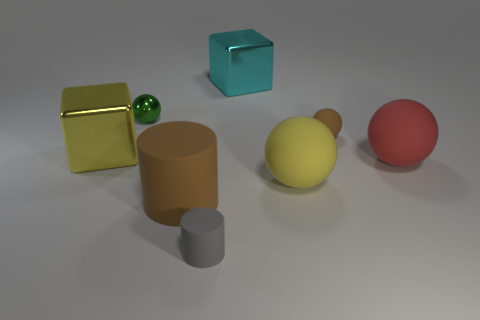There is a yellow thing that is to the right of the brown thing that is to the left of the tiny gray cylinder; how many gray rubber cylinders are behind it?
Your answer should be very brief. 0. There is a brown object on the right side of the small cylinder; what is its shape?
Your response must be concise. Sphere. How many other objects are the same material as the yellow block?
Make the answer very short. 2. Does the big matte cylinder have the same color as the small rubber cylinder?
Keep it short and to the point. No. Are there fewer red balls on the left side of the large brown rubber object than cylinders that are on the left side of the small gray cylinder?
Your answer should be compact. Yes. What is the color of the metal thing that is the same shape as the red rubber thing?
Your answer should be compact. Green. There is a cube in front of the brown sphere; does it have the same size as the small rubber cylinder?
Provide a short and direct response. No. Is the number of large red rubber objects that are to the left of the small green metal thing less than the number of big purple shiny objects?
Give a very brief answer. No. Is there any other thing that has the same size as the yellow shiny block?
Provide a succinct answer. Yes. What is the size of the rubber cylinder that is to the right of the brown matte object that is to the left of the large cyan block?
Keep it short and to the point. Small. 